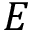<formula> <loc_0><loc_0><loc_500><loc_500>E</formula> 